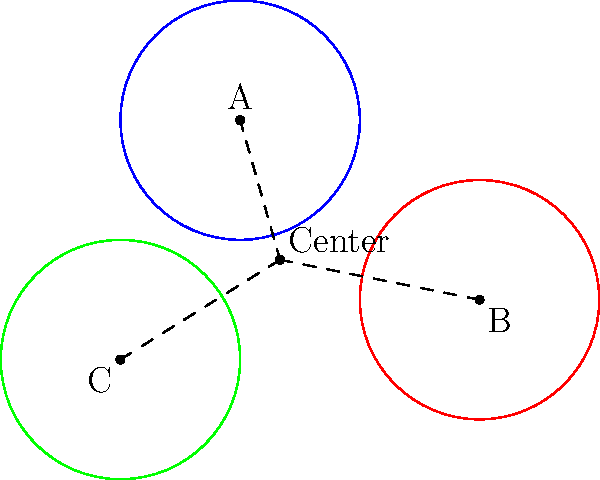In a complex legal debate, three key arguments are represented by circles centered at points A(0,3), B(4,0), and C(-2,-1), each with a radius of 2 units. The intersection point of these circles symbolizes the core issue of the debate. Find the coordinates of this intersection point (the center of the circle passing through A, B, and C). To find the center of the circle passing through points A, B, and C, we can use the perpendicular bisector method:

1) First, we need to find the midpoints of two sides of the triangle ABC:
   Midpoint of AB: $M_{AB} = (\frac{0+4}{2}, \frac{3+0}{2}) = (2, \frac{3}{2})$
   Midpoint of BC: $M_{BC} = (\frac{4-2}{2}, \frac{0-1}{2}) = (1, -\frac{1}{2})$

2) Now, we need to find the slopes of AB and BC:
   Slope of AB: $m_{AB} = \frac{0-3}{4-0} = -\frac{3}{4}$
   Slope of BC: $m_{BC} = \frac{-1-0}{-2-4} = \frac{1}{6}$

3) The perpendicular bisectors will have slopes that are negative reciprocals of these:
   Slope of perpendicular bisector of AB: $m_1 = \frac{4}{3}$
   Slope of perpendicular bisector of BC: $m_2 = -6$

4) We can now write equations for these perpendicular bisectors:
   Bisector of AB: $y - \frac{3}{2} = \frac{4}{3}(x - 2)$
   Bisector of BC: $y + \frac{1}{2} = -6(x - 1)$

5) To find the intersection of these lines (which is the center of the circle), we solve these equations simultaneously:
   $y = \frac{4}{3}x - \frac{5}{3}$
   $y = -6x + \frac{11}{2}$

6) Equating these:
   $\frac{4}{3}x - \frac{5}{3} = -6x + \frac{11}{2}$

7) Solving for x:
   $\frac{22}{3}x = \frac{11}{2} + \frac{5}{3} = \frac{33}{6} + \frac{5}{3} = \frac{22}{6} = \frac{11}{3}$
   $x = \frac{2}{3}$

8) Substituting this back into either equation for y:
   $y = \frac{4}{3}(\frac{2}{3}) - \frac{5}{3} = \frac{8}{9} - \frac{5}{3} = \frac{2}{3}$

Therefore, the center of the circle (the core issue of the debate) is at $(\frac{2}{3}, \frac{2}{3})$.
Answer: $(\frac{2}{3}, \frac{2}{3})$ 